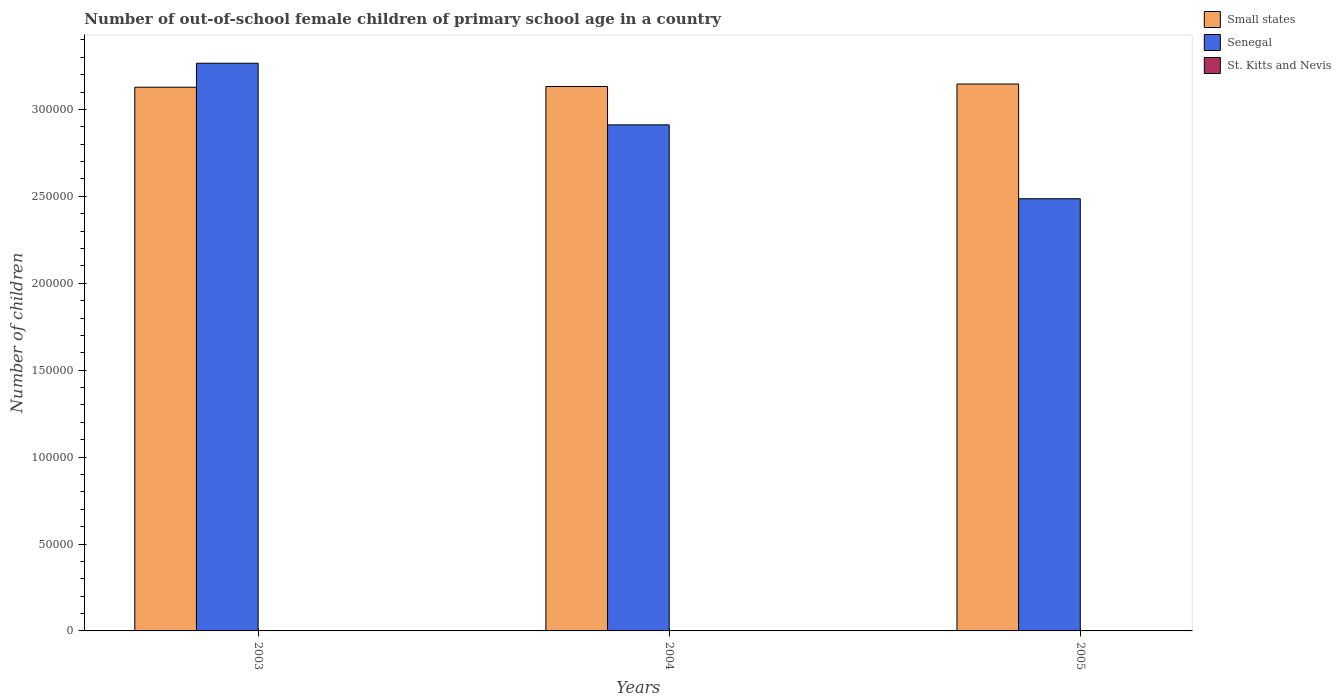How many groups of bars are there?
Provide a succinct answer. 3. How many bars are there on the 2nd tick from the left?
Offer a very short reply. 3. How many bars are there on the 1st tick from the right?
Offer a terse response. 3. What is the label of the 2nd group of bars from the left?
Give a very brief answer. 2004. In how many cases, is the number of bars for a given year not equal to the number of legend labels?
Make the answer very short. 0. What is the number of out-of-school female children in Small states in 2005?
Provide a succinct answer. 3.15e+05. Across all years, what is the maximum number of out-of-school female children in Small states?
Make the answer very short. 3.15e+05. Across all years, what is the minimum number of out-of-school female children in Small states?
Ensure brevity in your answer.  3.13e+05. In which year was the number of out-of-school female children in Senegal minimum?
Provide a short and direct response. 2005. What is the total number of out-of-school female children in Senegal in the graph?
Provide a succinct answer. 8.66e+05. What is the difference between the number of out-of-school female children in St. Kitts and Nevis in 2003 and that in 2005?
Ensure brevity in your answer.  -53. What is the difference between the number of out-of-school female children in Small states in 2005 and the number of out-of-school female children in St. Kitts and Nevis in 2004?
Offer a terse response. 3.15e+05. What is the average number of out-of-school female children in St. Kitts and Nevis per year?
Your answer should be compact. 63.33. In the year 2003, what is the difference between the number of out-of-school female children in Senegal and number of out-of-school female children in St. Kitts and Nevis?
Provide a short and direct response. 3.26e+05. In how many years, is the number of out-of-school female children in Small states greater than 320000?
Provide a succinct answer. 0. What is the ratio of the number of out-of-school female children in Small states in 2003 to that in 2004?
Provide a succinct answer. 1. Is the number of out-of-school female children in St. Kitts and Nevis in 2004 less than that in 2005?
Offer a very short reply. Yes. Is the difference between the number of out-of-school female children in Senegal in 2003 and 2004 greater than the difference between the number of out-of-school female children in St. Kitts and Nevis in 2003 and 2004?
Provide a succinct answer. Yes. What is the difference between the highest and the second highest number of out-of-school female children in Small states?
Keep it short and to the point. 1418. What is the difference between the highest and the lowest number of out-of-school female children in Senegal?
Make the answer very short. 7.79e+04. Is the sum of the number of out-of-school female children in St. Kitts and Nevis in 2003 and 2004 greater than the maximum number of out-of-school female children in Small states across all years?
Ensure brevity in your answer.  No. What does the 2nd bar from the left in 2005 represents?
Your response must be concise. Senegal. What does the 1st bar from the right in 2003 represents?
Ensure brevity in your answer.  St. Kitts and Nevis. Is it the case that in every year, the sum of the number of out-of-school female children in Senegal and number of out-of-school female children in Small states is greater than the number of out-of-school female children in St. Kitts and Nevis?
Your answer should be compact. Yes. How many years are there in the graph?
Your response must be concise. 3. Does the graph contain any zero values?
Keep it short and to the point. No. Where does the legend appear in the graph?
Keep it short and to the point. Top right. What is the title of the graph?
Keep it short and to the point. Number of out-of-school female children of primary school age in a country. What is the label or title of the X-axis?
Ensure brevity in your answer.  Years. What is the label or title of the Y-axis?
Ensure brevity in your answer.  Number of children. What is the Number of children in Small states in 2003?
Your answer should be very brief. 3.13e+05. What is the Number of children of Senegal in 2003?
Provide a short and direct response. 3.27e+05. What is the Number of children of Small states in 2004?
Make the answer very short. 3.13e+05. What is the Number of children in Senegal in 2004?
Give a very brief answer. 2.91e+05. What is the Number of children in St. Kitts and Nevis in 2004?
Offer a very short reply. 25. What is the Number of children of Small states in 2005?
Give a very brief answer. 3.15e+05. What is the Number of children of Senegal in 2005?
Provide a succinct answer. 2.49e+05. What is the Number of children of St. Kitts and Nevis in 2005?
Your response must be concise. 109. Across all years, what is the maximum Number of children of Small states?
Provide a short and direct response. 3.15e+05. Across all years, what is the maximum Number of children in Senegal?
Your answer should be very brief. 3.27e+05. Across all years, what is the maximum Number of children in St. Kitts and Nevis?
Keep it short and to the point. 109. Across all years, what is the minimum Number of children of Small states?
Ensure brevity in your answer.  3.13e+05. Across all years, what is the minimum Number of children of Senegal?
Your answer should be compact. 2.49e+05. What is the total Number of children of Small states in the graph?
Your answer should be compact. 9.41e+05. What is the total Number of children in Senegal in the graph?
Provide a short and direct response. 8.66e+05. What is the total Number of children in St. Kitts and Nevis in the graph?
Give a very brief answer. 190. What is the difference between the Number of children in Small states in 2003 and that in 2004?
Provide a short and direct response. -411. What is the difference between the Number of children of Senegal in 2003 and that in 2004?
Your response must be concise. 3.54e+04. What is the difference between the Number of children of Small states in 2003 and that in 2005?
Offer a very short reply. -1829. What is the difference between the Number of children of Senegal in 2003 and that in 2005?
Give a very brief answer. 7.79e+04. What is the difference between the Number of children of St. Kitts and Nevis in 2003 and that in 2005?
Offer a terse response. -53. What is the difference between the Number of children in Small states in 2004 and that in 2005?
Your answer should be very brief. -1418. What is the difference between the Number of children in Senegal in 2004 and that in 2005?
Your answer should be very brief. 4.25e+04. What is the difference between the Number of children of St. Kitts and Nevis in 2004 and that in 2005?
Give a very brief answer. -84. What is the difference between the Number of children of Small states in 2003 and the Number of children of Senegal in 2004?
Your answer should be very brief. 2.17e+04. What is the difference between the Number of children of Small states in 2003 and the Number of children of St. Kitts and Nevis in 2004?
Provide a short and direct response. 3.13e+05. What is the difference between the Number of children of Senegal in 2003 and the Number of children of St. Kitts and Nevis in 2004?
Make the answer very short. 3.27e+05. What is the difference between the Number of children in Small states in 2003 and the Number of children in Senegal in 2005?
Make the answer very short. 6.42e+04. What is the difference between the Number of children in Small states in 2003 and the Number of children in St. Kitts and Nevis in 2005?
Offer a terse response. 3.13e+05. What is the difference between the Number of children of Senegal in 2003 and the Number of children of St. Kitts and Nevis in 2005?
Make the answer very short. 3.26e+05. What is the difference between the Number of children in Small states in 2004 and the Number of children in Senegal in 2005?
Your answer should be very brief. 6.46e+04. What is the difference between the Number of children in Small states in 2004 and the Number of children in St. Kitts and Nevis in 2005?
Your answer should be very brief. 3.13e+05. What is the difference between the Number of children in Senegal in 2004 and the Number of children in St. Kitts and Nevis in 2005?
Offer a very short reply. 2.91e+05. What is the average Number of children of Small states per year?
Your response must be concise. 3.14e+05. What is the average Number of children in Senegal per year?
Keep it short and to the point. 2.89e+05. What is the average Number of children in St. Kitts and Nevis per year?
Offer a very short reply. 63.33. In the year 2003, what is the difference between the Number of children of Small states and Number of children of Senegal?
Offer a terse response. -1.38e+04. In the year 2003, what is the difference between the Number of children of Small states and Number of children of St. Kitts and Nevis?
Ensure brevity in your answer.  3.13e+05. In the year 2003, what is the difference between the Number of children in Senegal and Number of children in St. Kitts and Nevis?
Give a very brief answer. 3.26e+05. In the year 2004, what is the difference between the Number of children of Small states and Number of children of Senegal?
Ensure brevity in your answer.  2.21e+04. In the year 2004, what is the difference between the Number of children in Small states and Number of children in St. Kitts and Nevis?
Ensure brevity in your answer.  3.13e+05. In the year 2004, what is the difference between the Number of children of Senegal and Number of children of St. Kitts and Nevis?
Provide a succinct answer. 2.91e+05. In the year 2005, what is the difference between the Number of children in Small states and Number of children in Senegal?
Keep it short and to the point. 6.60e+04. In the year 2005, what is the difference between the Number of children in Small states and Number of children in St. Kitts and Nevis?
Your answer should be compact. 3.14e+05. In the year 2005, what is the difference between the Number of children in Senegal and Number of children in St. Kitts and Nevis?
Keep it short and to the point. 2.48e+05. What is the ratio of the Number of children of Small states in 2003 to that in 2004?
Keep it short and to the point. 1. What is the ratio of the Number of children in Senegal in 2003 to that in 2004?
Keep it short and to the point. 1.12. What is the ratio of the Number of children in St. Kitts and Nevis in 2003 to that in 2004?
Your response must be concise. 2.24. What is the ratio of the Number of children in Senegal in 2003 to that in 2005?
Make the answer very short. 1.31. What is the ratio of the Number of children in St. Kitts and Nevis in 2003 to that in 2005?
Your answer should be compact. 0.51. What is the ratio of the Number of children of Senegal in 2004 to that in 2005?
Ensure brevity in your answer.  1.17. What is the ratio of the Number of children in St. Kitts and Nevis in 2004 to that in 2005?
Your answer should be compact. 0.23. What is the difference between the highest and the second highest Number of children of Small states?
Offer a terse response. 1418. What is the difference between the highest and the second highest Number of children of Senegal?
Offer a very short reply. 3.54e+04. What is the difference between the highest and the second highest Number of children of St. Kitts and Nevis?
Your response must be concise. 53. What is the difference between the highest and the lowest Number of children in Small states?
Your answer should be very brief. 1829. What is the difference between the highest and the lowest Number of children of Senegal?
Provide a succinct answer. 7.79e+04. What is the difference between the highest and the lowest Number of children of St. Kitts and Nevis?
Provide a short and direct response. 84. 